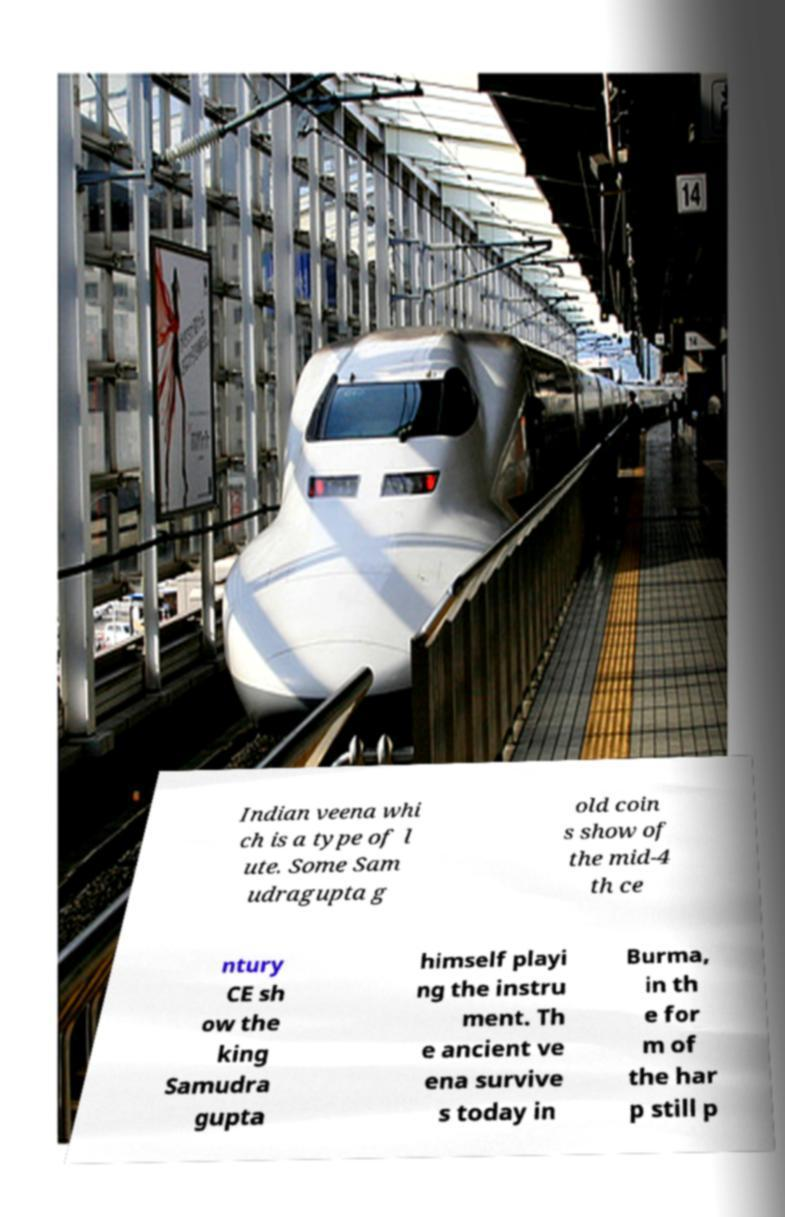There's text embedded in this image that I need extracted. Can you transcribe it verbatim? Indian veena whi ch is a type of l ute. Some Sam udragupta g old coin s show of the mid-4 th ce ntury CE sh ow the king Samudra gupta himself playi ng the instru ment. Th e ancient ve ena survive s today in Burma, in th e for m of the har p still p 